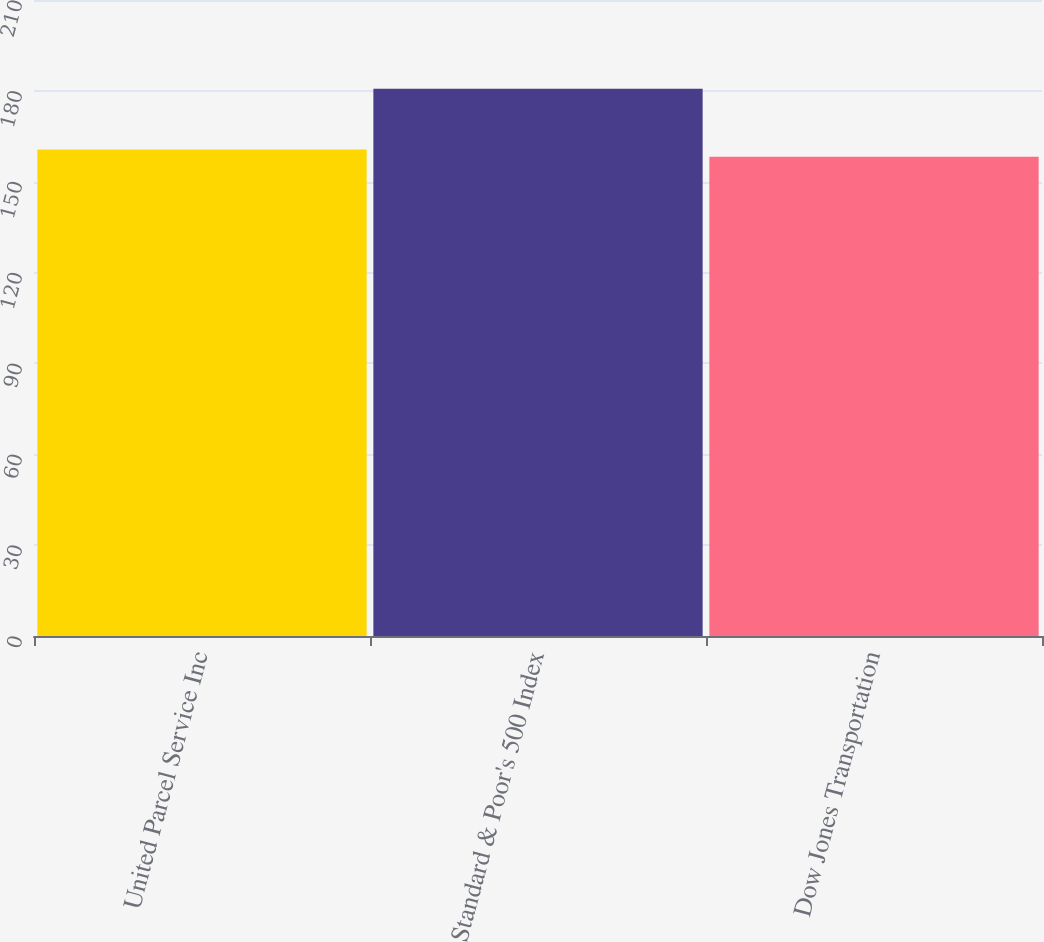Convert chart to OTSL. <chart><loc_0><loc_0><loc_500><loc_500><bar_chart><fcel>United Parcel Service Inc<fcel>Standard & Poor's 500 Index<fcel>Dow Jones Transportation<nl><fcel>160.61<fcel>180.67<fcel>158.23<nl></chart> 